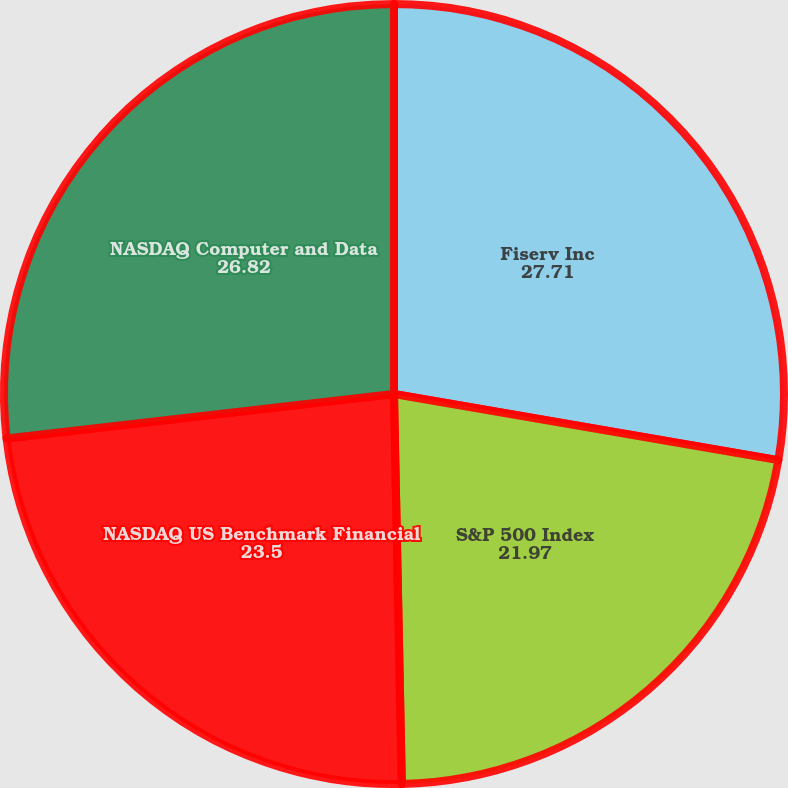Convert chart to OTSL. <chart><loc_0><loc_0><loc_500><loc_500><pie_chart><fcel>Fiserv Inc<fcel>S&P 500 Index<fcel>NASDAQ US Benchmark Financial<fcel>NASDAQ Computer and Data<nl><fcel>27.71%<fcel>21.97%<fcel>23.5%<fcel>26.82%<nl></chart> 